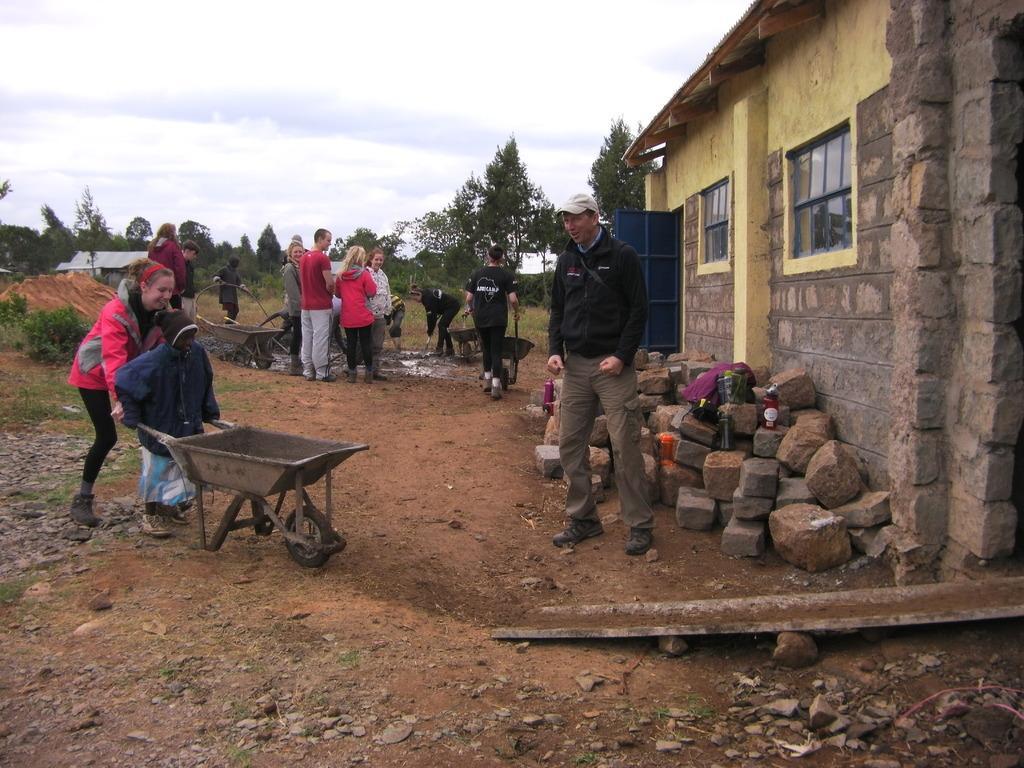Can you describe this image briefly? On the right side there is a building with windows and brick wall. Near to that there are stones. On that there are bottles. There are many people. Some are holding wheelbarrows. In the background there are trees and sky. 